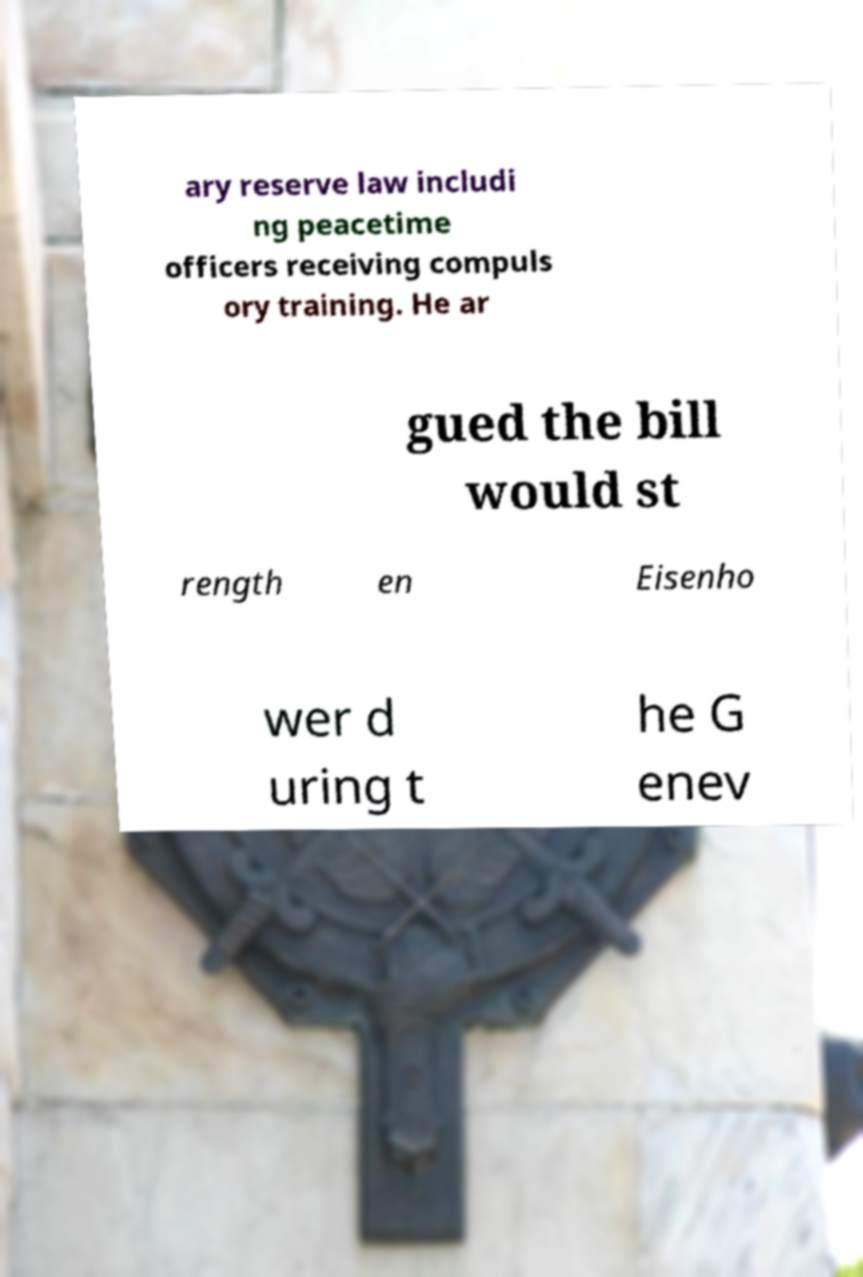For documentation purposes, I need the text within this image transcribed. Could you provide that? ary reserve law includi ng peacetime officers receiving compuls ory training. He ar gued the bill would st rength en Eisenho wer d uring t he G enev 